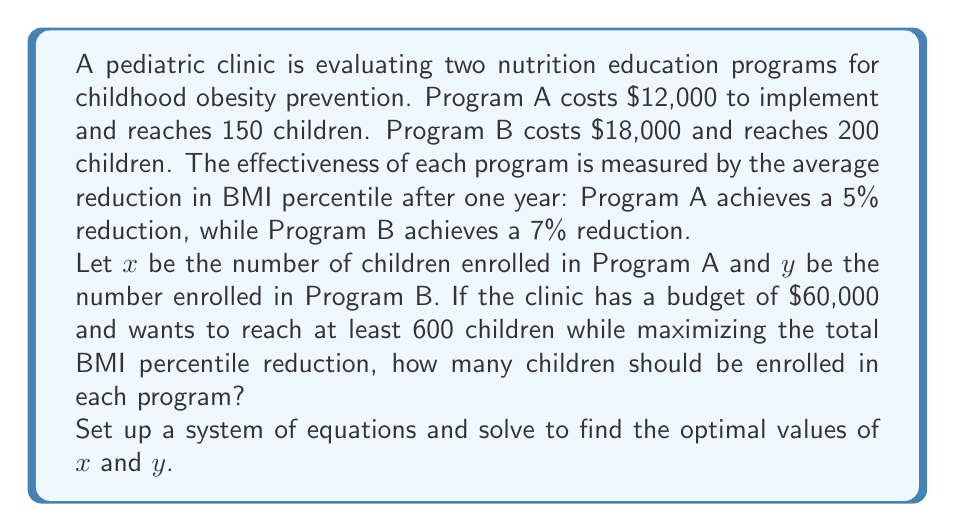Give your solution to this math problem. To solve this problem, we need to set up a system of equations based on the given constraints and then maximize the objective function. Let's approach this step-by-step:

1. Budget constraint:
   Cost of Program A + Cost of Program B ≤ Total budget
   $\frac{12000}{150}x + \frac{18000}{200}y \leq 60000$
   Simplifying: $80x + 90y \leq 60000$ (1)

2. Minimum number of children constraint:
   $x + y \geq 600$ (2)

3. Objective function to maximize:
   Total BMI percentile reduction = $5\%x + 7\%y = 0.05x + 0.07y$

Now, we need to find the maximum value of the objective function subject to constraints (1) and (2). We can use the corner point method:

4. Find the corner points:
   a) $x = 0, y = 600$: Satisfies (2) but not (1)
   b) $x = 600, y = 0$: Satisfies both constraints
   c) Intersection of (1) and (2):
      $80x + 90(600-x) = 60000$
      $80x + 54000 - 90x = 60000$
      $-10x = 6000$
      $x = 600$, $y = 0$

5. Evaluate the objective function at the feasible corner point:
   At $(600, 0)$: $0.05(600) + 0.07(0) = 30$

Therefore, the optimal solution is to enroll 600 children in Program A and 0 children in Program B.
Answer: Program A: 600 children; Program B: 0 children 